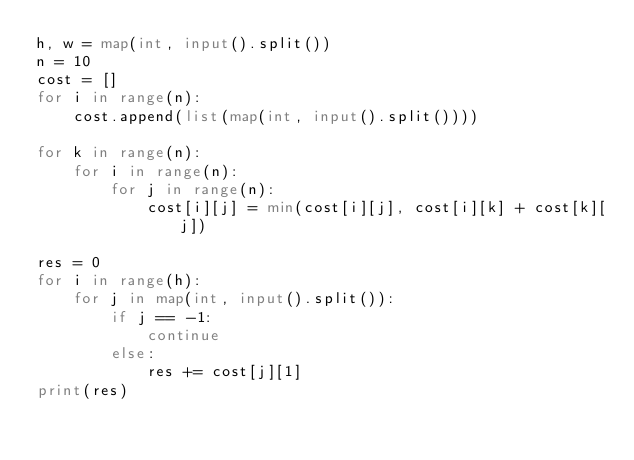Convert code to text. <code><loc_0><loc_0><loc_500><loc_500><_Python_>h, w = map(int, input().split())
n = 10
cost = []
for i in range(n):
    cost.append(list(map(int, input().split())))

for k in range(n):
    for i in range(n):
        for j in range(n):
            cost[i][j] = min(cost[i][j], cost[i][k] + cost[k][j])

res = 0
for i in range(h):
    for j in map(int, input().split()):
        if j == -1:
            continue
        else:
            res += cost[j][1]
print(res)
</code> 